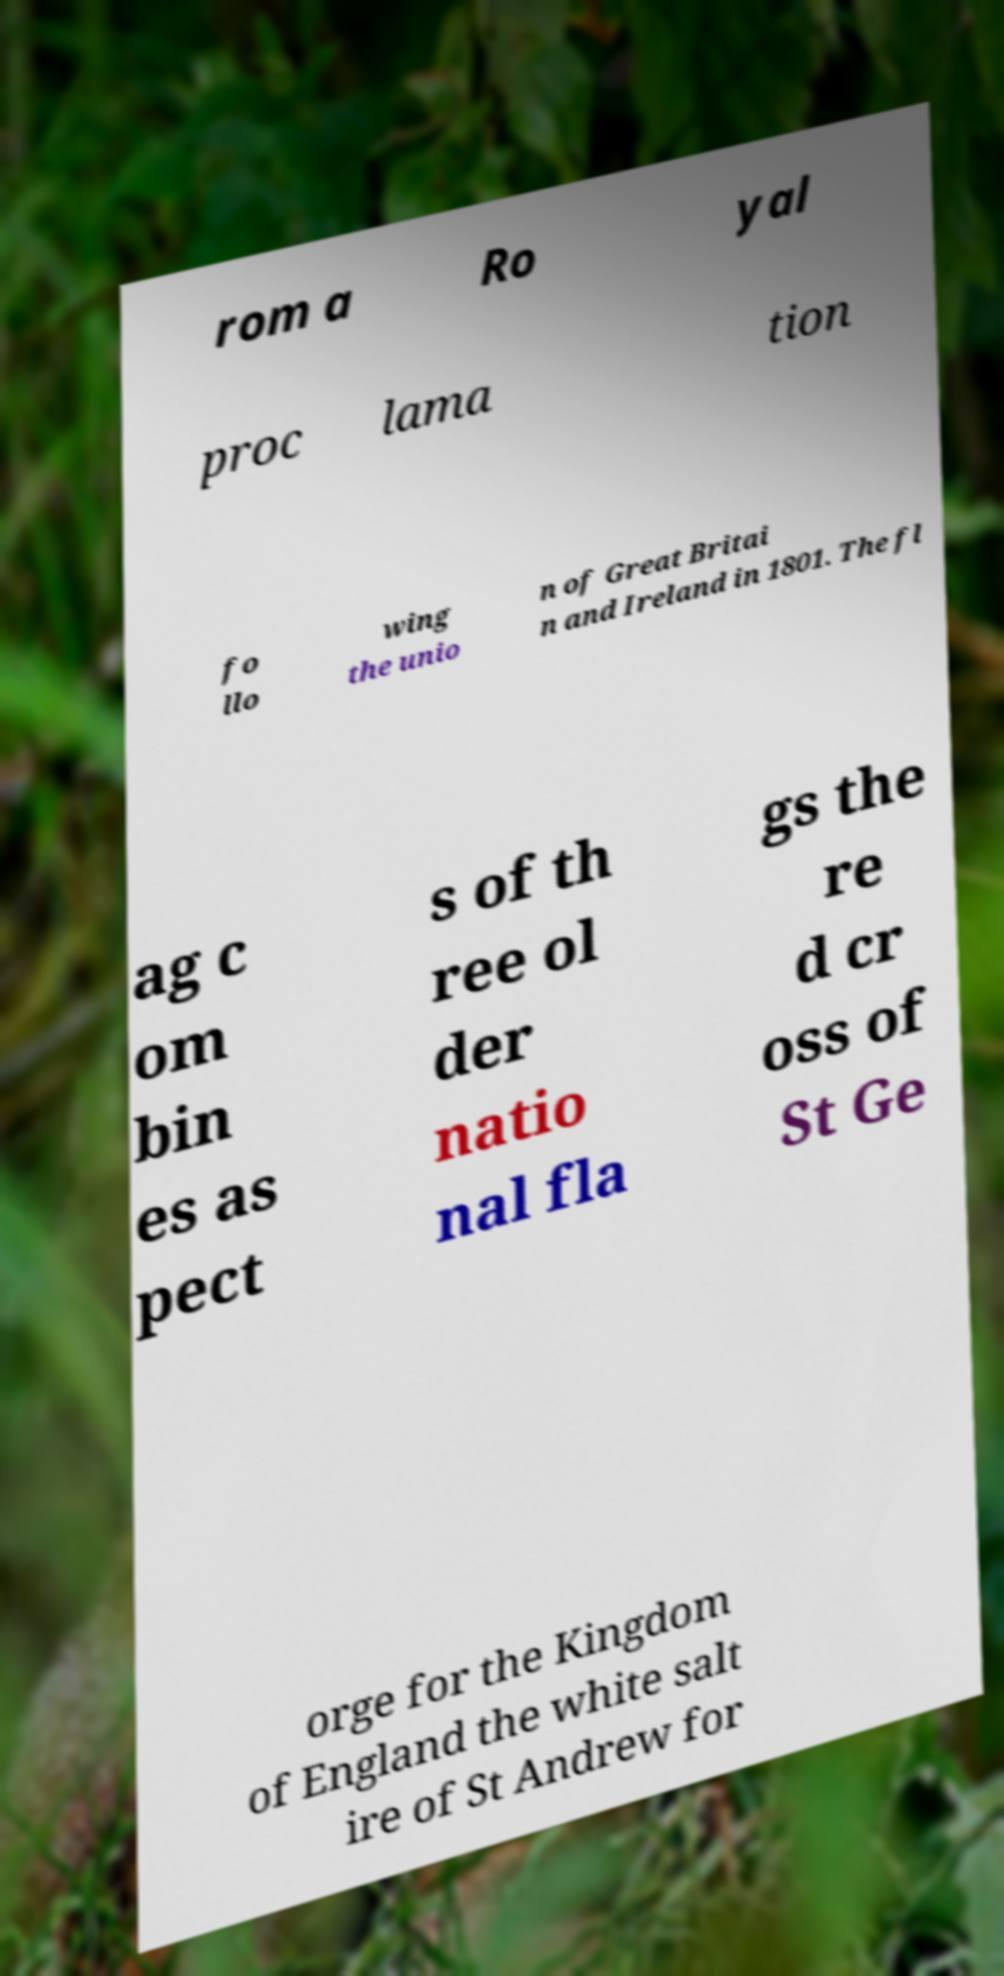There's text embedded in this image that I need extracted. Can you transcribe it verbatim? rom a Ro yal proc lama tion fo llo wing the unio n of Great Britai n and Ireland in 1801. The fl ag c om bin es as pect s of th ree ol der natio nal fla gs the re d cr oss of St Ge orge for the Kingdom of England the white salt ire of St Andrew for 